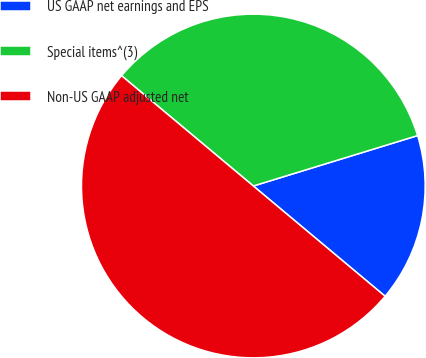Convert chart. <chart><loc_0><loc_0><loc_500><loc_500><pie_chart><fcel>US GAAP net earnings and EPS<fcel>Special items^(3)<fcel>Non-US GAAP adjusted net<nl><fcel>15.83%<fcel>34.17%<fcel>50.0%<nl></chart> 